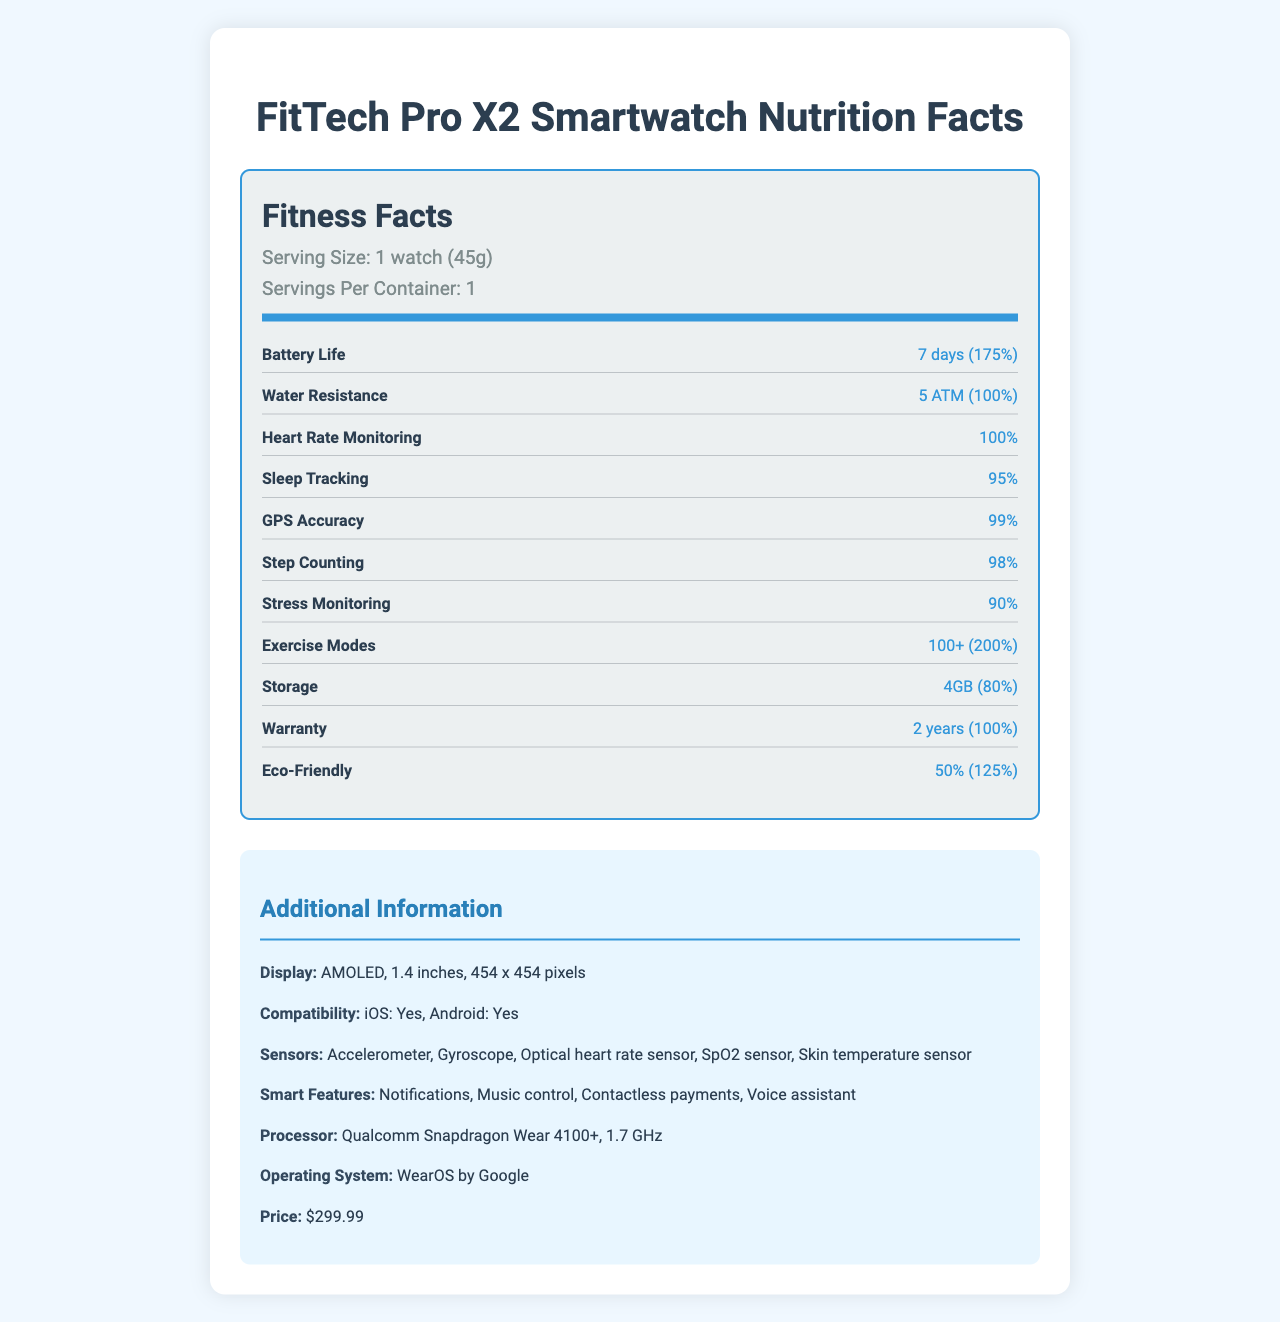what is the serving size of the FitTech Pro X2 Smartwatch? The serving size is mentioned as "1 watch (45g)" in the document.
Answer: 1 watch (45g) how long is the battery life of the FitTech Pro X2 Smartwatch? The battery life is mentioned under the fitness facts section as "7 days (175%)".
Answer: 7 days what type of display does the FitTech Pro X2 Smartwatch have? The display type is listed in the additional information section as "AMOLED".
Answer: AMOLED is the FitTech Pro X2 Smartwatch water-resistant? The document states that the water resistance rating is "5 ATM (100%)".
Answer: Yes how many exercise modes does the FitTech Pro X2 Smartwatch support? The document lists "Exercise Modes: 100+ (200%)".
Answer: 100+ which operating system does the FitTech Pro X2 Smartwatch use? A. Android Wear B. watchOS C. WearOS by Google D. Tizen The document lists the operating system as "WearOS by Google".
Answer: C how much storage capacity does the FitTech Pro X2 Smartwatch offer? A. 2GB B. 4GB C. 8GB D. 16GB The storage capacity is stated as "4GB (80%)".
Answer: B does the FitTech Pro X2 Smartwatch support iOS devices? Under the compatibility section, it is stated that the smartwatch is compatible with iOS.
Answer: Yes is the heart rate monitoring feature fully effective? The heart rate monitoring feature has a daily value of 100%, indicating full effectiveness.
Answer: Yes describe the main features and specifications of the FitTech Pro X2 Smartwatch. This summary captures the main elements including fitness features, specifications, compatibility, and price.
Answer: The FitTech Pro X2 Smartwatch is a high-tech gadget with a variety of features including heart rate monitoring (100%), sleep tracking (95%), GPS accuracy (99%), step counting (98%), and stress monitoring (90%). It has a battery life of 7 days (175%), water resistance of 5 ATM (100%), and an AMOLED display. The smartwatch supports over 100 exercise modes (200%), has 4GB of storage (80%), and comes with a 2-year warranty (100%). It's compatible with both iOS and Android, features various sensors like the accelerometer, gyroscope, and SpO2 sensor, and offers smart features such as notifications and contactless payments. It runs on WearOS by Google and is priced at $299.99. what is the exact daily value for the step-counting feature? The document specifies step counting's daily value as 98%.
Answer: 98% what processor does the FitTech Pro X2 Smartwatch use? The additional info section mentions the processor type as "Qualcomm Snapdragon Wear 4100+".
Answer: Qualcomm Snapdragon Wear 4100+ how many sensors are listed in the document for the FitTech Pro X2 Smartwatch? The document lists five sensors: Accelerometer, Gyroscope, Optical heart rate sensor, SpO2 sensor, Skin temperature sensor.
Answer: 5 what color options are available for the FitTech Pro X2 Smartwatch? The document does not provide any information regarding the color options available for the smartwatch.
Answer: Not enough information 